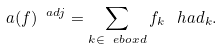<formula> <loc_0><loc_0><loc_500><loc_500>a ( f ) ^ { \ a d j } = \sum _ { k \in \ e b o x d } f _ { k } \, \ h a d _ { k } .</formula> 